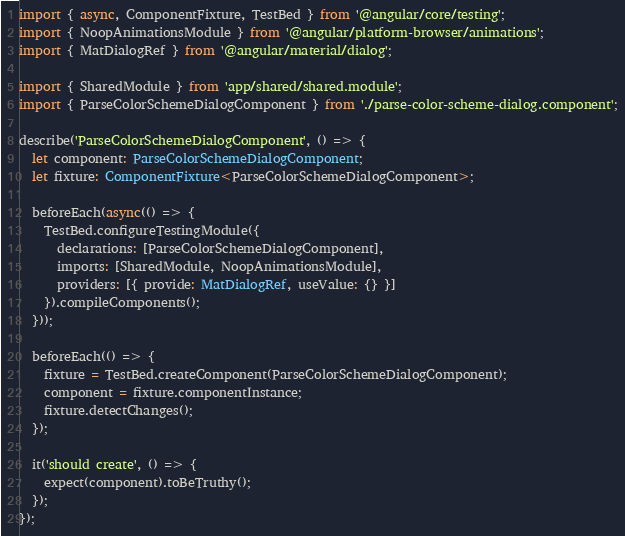Convert code to text. <code><loc_0><loc_0><loc_500><loc_500><_TypeScript_>import { async, ComponentFixture, TestBed } from '@angular/core/testing';
import { NoopAnimationsModule } from '@angular/platform-browser/animations';
import { MatDialogRef } from '@angular/material/dialog';

import { SharedModule } from 'app/shared/shared.module';
import { ParseColorSchemeDialogComponent } from './parse-color-scheme-dialog.component';

describe('ParseColorSchemeDialogComponent', () => {
  let component: ParseColorSchemeDialogComponent;
  let fixture: ComponentFixture<ParseColorSchemeDialogComponent>;

  beforeEach(async(() => {
    TestBed.configureTestingModule({
      declarations: [ParseColorSchemeDialogComponent],
      imports: [SharedModule, NoopAnimationsModule],
      providers: [{ provide: MatDialogRef, useValue: {} }]
    }).compileComponents();
  }));

  beforeEach(() => {
    fixture = TestBed.createComponent(ParseColorSchemeDialogComponent);
    component = fixture.componentInstance;
    fixture.detectChanges();
  });

  it('should create', () => {
    expect(component).toBeTruthy();
  });
});
</code> 